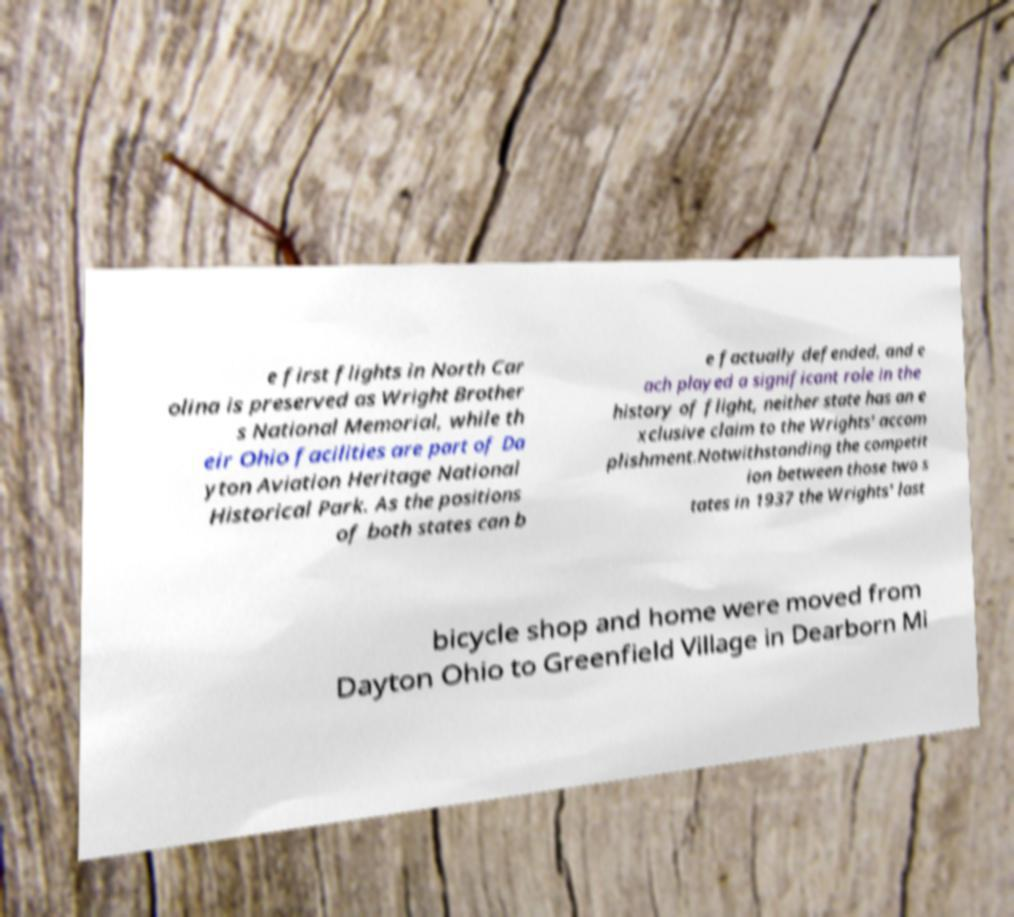There's text embedded in this image that I need extracted. Can you transcribe it verbatim? e first flights in North Car olina is preserved as Wright Brother s National Memorial, while th eir Ohio facilities are part of Da yton Aviation Heritage National Historical Park. As the positions of both states can b e factually defended, and e ach played a significant role in the history of flight, neither state has an e xclusive claim to the Wrights' accom plishment.Notwithstanding the competit ion between those two s tates in 1937 the Wrights' last bicycle shop and home were moved from Dayton Ohio to Greenfield Village in Dearborn Mi 